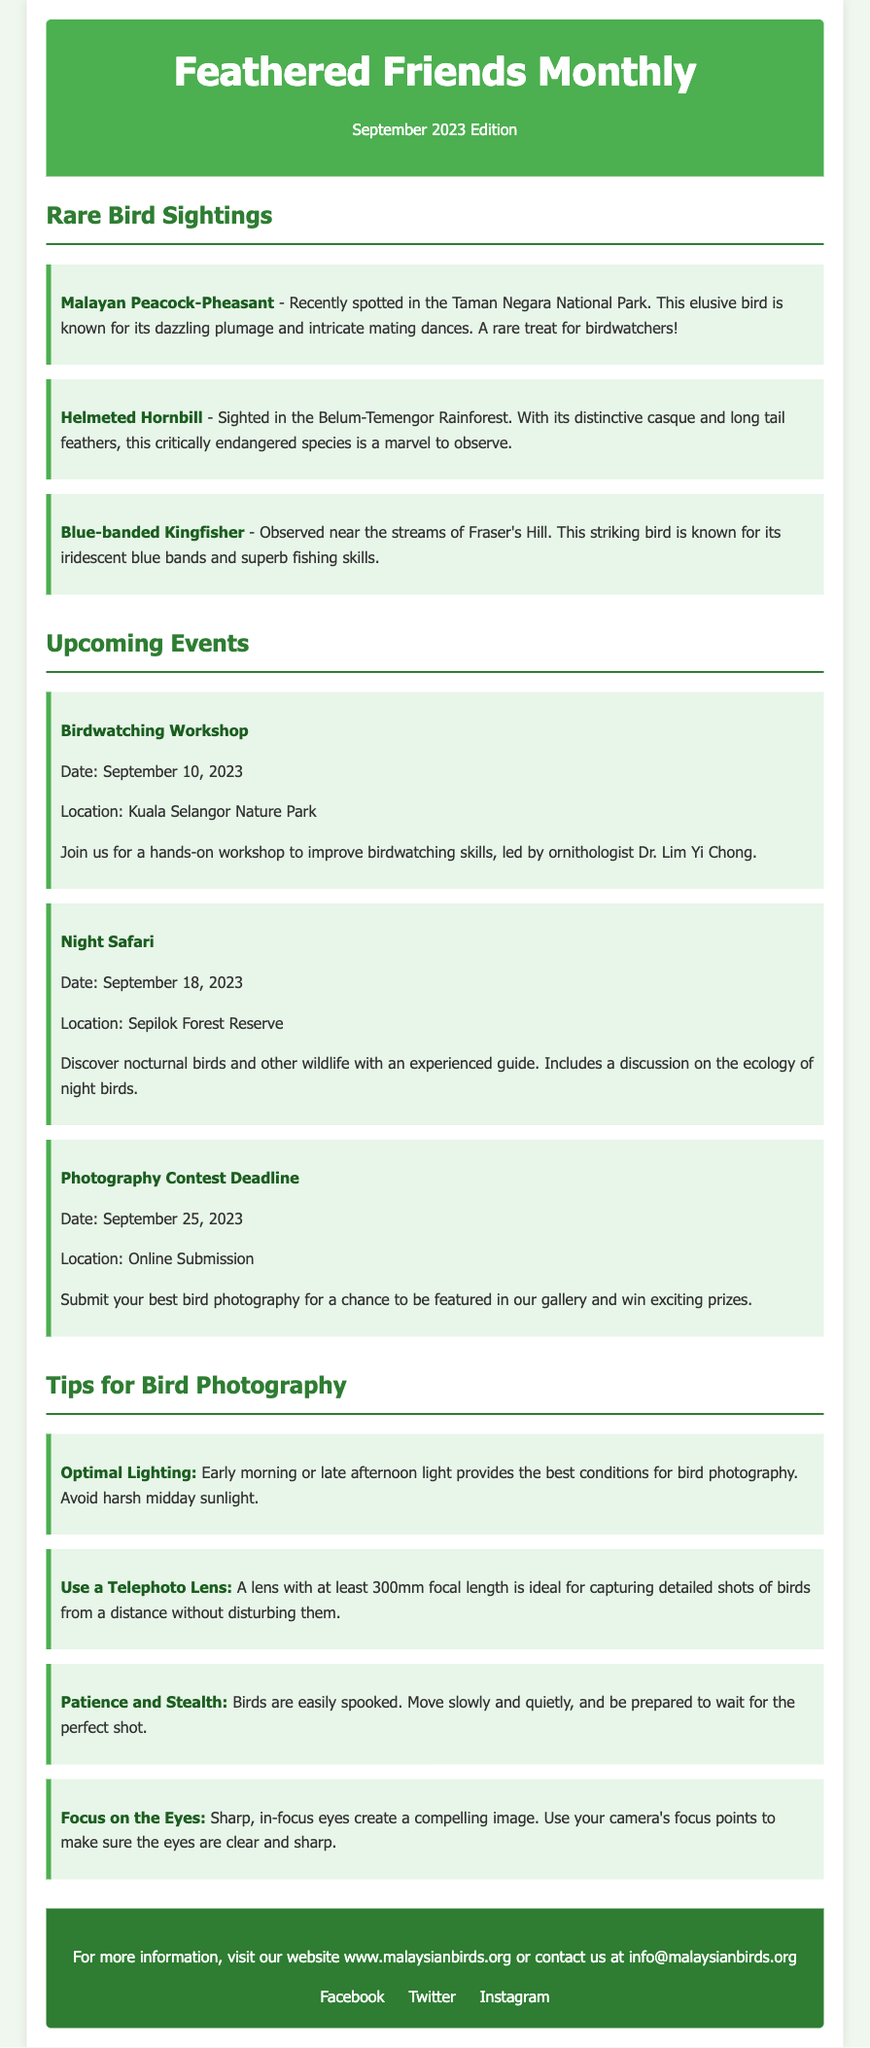What is the title of the newsletter? The title of the newsletter is displayed prominently at the top of the document.
Answer: Feathered Friends Monthly When is the Birdwatching Workshop? The date for the Birdwatching Workshop is mentioned in the events section.
Answer: September 10, 2023 What endangered bird was spotted in the Belum-Temengor Rainforest? The document lists specific rare birds along with their locations.
Answer: Helmeted Hornbill How many photography tips are included in the newsletter? The number of tips is found by counting the entries in the photography tips section.
Answer: Four What location is highlighted for the Night Safari? The location for the Night Safari is specified in the event section of the document.
Answer: Sepilok Forest Reserve What type of lens is recommended for bird photography? The document provides specific advice for bird photography, indicating the type of lens suitable.
Answer: Telephoto Lens What color is the header of the newsletter? The color of the header can be inferred from the document's visual description.
Answer: Green What are the best times for optimal lighting in bird photography? The document specifies the best times for photography in a concise manner.
Answer: Early morning or late afternoon 